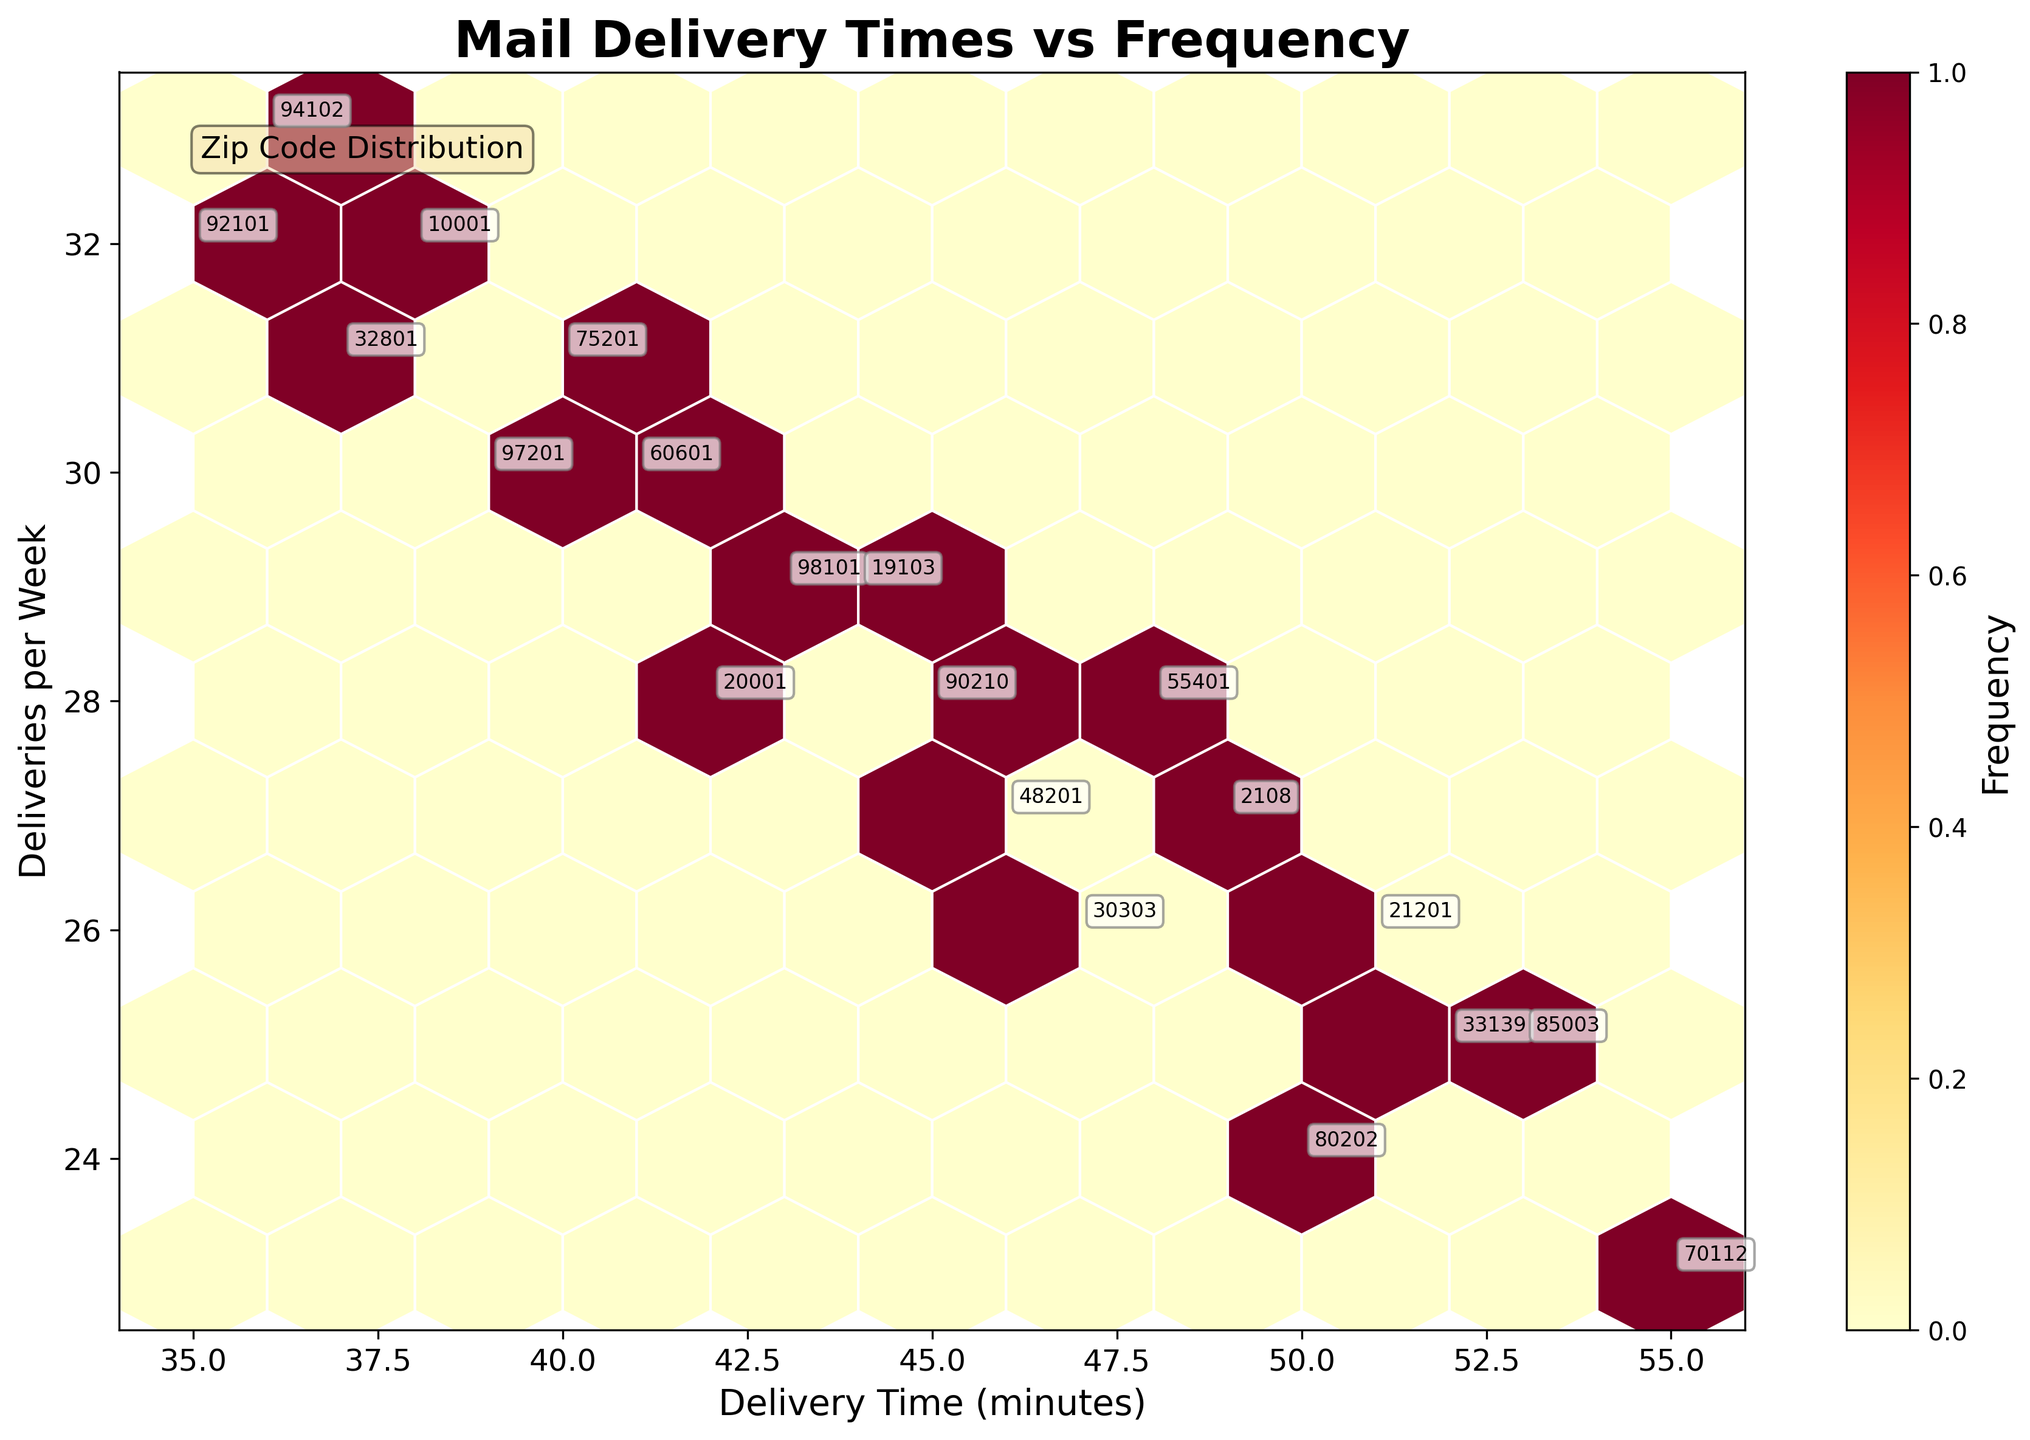What is the title of the plot? The title is written in a large font above the graph, stating what the plot represents.
Answer: Mail Delivery Times vs Frequency What is the color of the highest frequency hexagons? The hexagons with the highest frequency are represented with the most intense color in the colormap used.
Answer: Dark Red How many color bars are there in the plot? The plot contains a single color bar indicating the frequency of data points in each hexagon.
Answer: One On which axis is 'Delivery Time (minutes)' displayed? The x-axis label clearly states 'Delivery Time (minutes)'.
Answer: x-axis Which zipcode has the longest delivery time? By looking at the annotated zipcodes on the hexbin plot, identify the one with the longest delivery time.
Answer: 70112 What is the average delivery time in minutes for the zipcodes with the highest delivery frequencies? Sum the delivery times of the zipcodes with the highest number of deliveries and divide by the number of those zipcodes.
Answer: (52+38+47+40+36+41+50+44+46+51+55+53+49+48)/14 ≈ 45 minutes Which zipcode has the most deliveries per week? Locate the zipcode annotated at the highest point of the y-axis, indicating the most deliveries.
Answer: 94102 Do zipcodes with high delivery frequencies also tend to have shorter delivery times? Compare the positions of high-frequency hexagons along both axes to identify any relationship.
Answer: Yes What is the median delivery time (minutes) for all zipcodes? List all delivery times, order them, and find the middle value.
Answer: 45 minutes Which zipcode has the shortest delivery time? Identify the annotated zipcode located furthest to the left on the x-axis.
Answer: 92101 